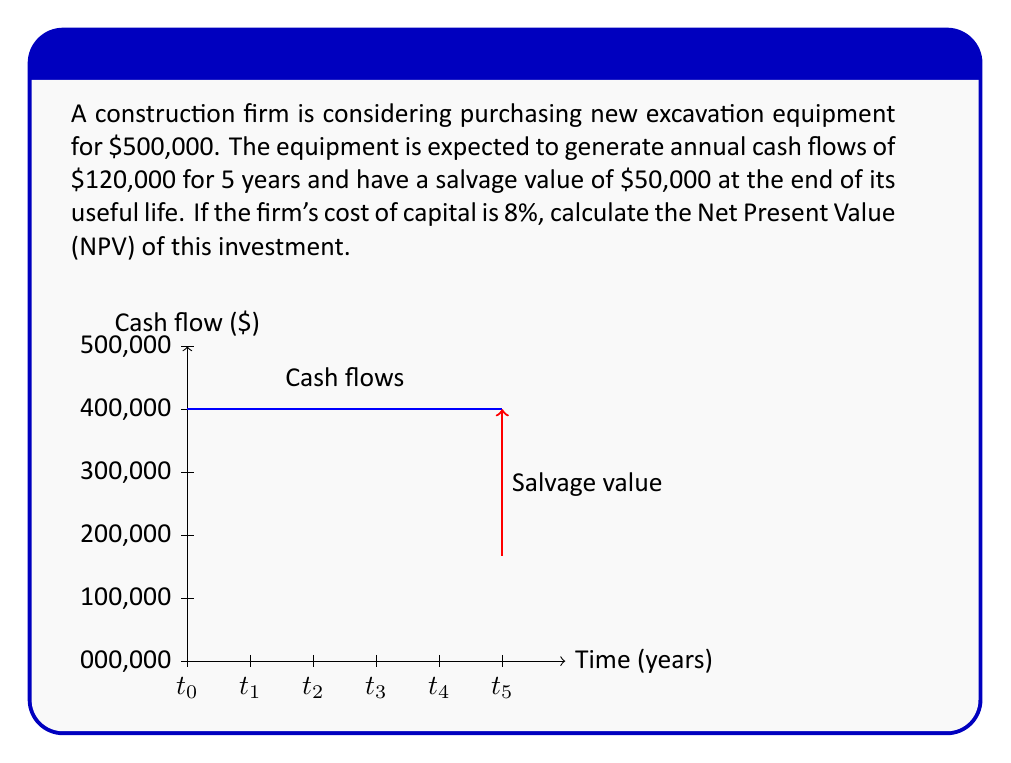Help me with this question. To calculate the Net Present Value (NPV), we need to follow these steps:

1) Calculate the present value of the annual cash flows:
   The present value of an annuity formula is used:
   $$PV_{annuity} = CF \times \frac{1-(1+r)^{-n}}{r}$$
   Where CF is the cash flow, r is the discount rate, and n is the number of periods.
   
   $$PV_{annuity} = 120000 \times \frac{1-(1+0.08)^{-5}}{0.08} = 480,018.79$$

2) Calculate the present value of the salvage value:
   $$PV_{salvage} = \frac{50000}{(1+0.08)^5} = 34,028.71$$

3) Sum up all the present values:
   $$Total PV = 480,018.79 + 34,028.71 = 514,047.50$$

4) Calculate NPV by subtracting the initial investment:
   $$NPV = Total PV - Initial Investment$$
   $$NPV = 514,047.50 - 500,000 = 14,047.50$$
Answer: $14,047.50 